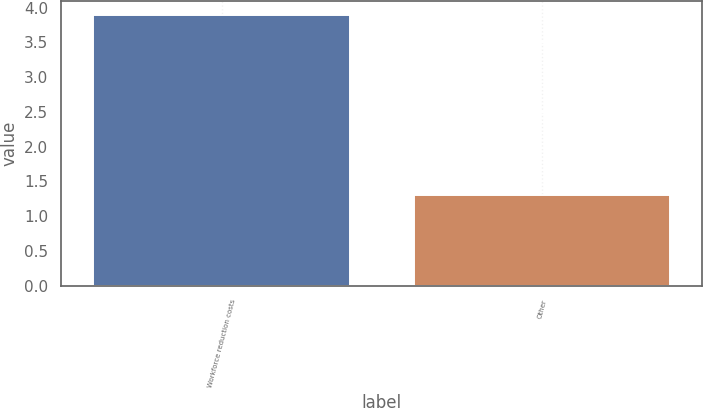Convert chart to OTSL. <chart><loc_0><loc_0><loc_500><loc_500><bar_chart><fcel>Workforce reduction costs<fcel>Other<nl><fcel>3.9<fcel>1.3<nl></chart> 